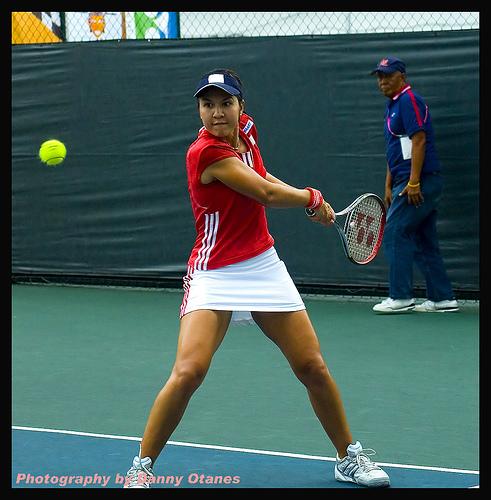How many white stripes are visible on the side of the red shirt closest to the viewer?
Answer briefly. 3. What color is the tennis ball?
Short answer required. Yellow. Is the man playing tennis as well?
Write a very short answer. No. 